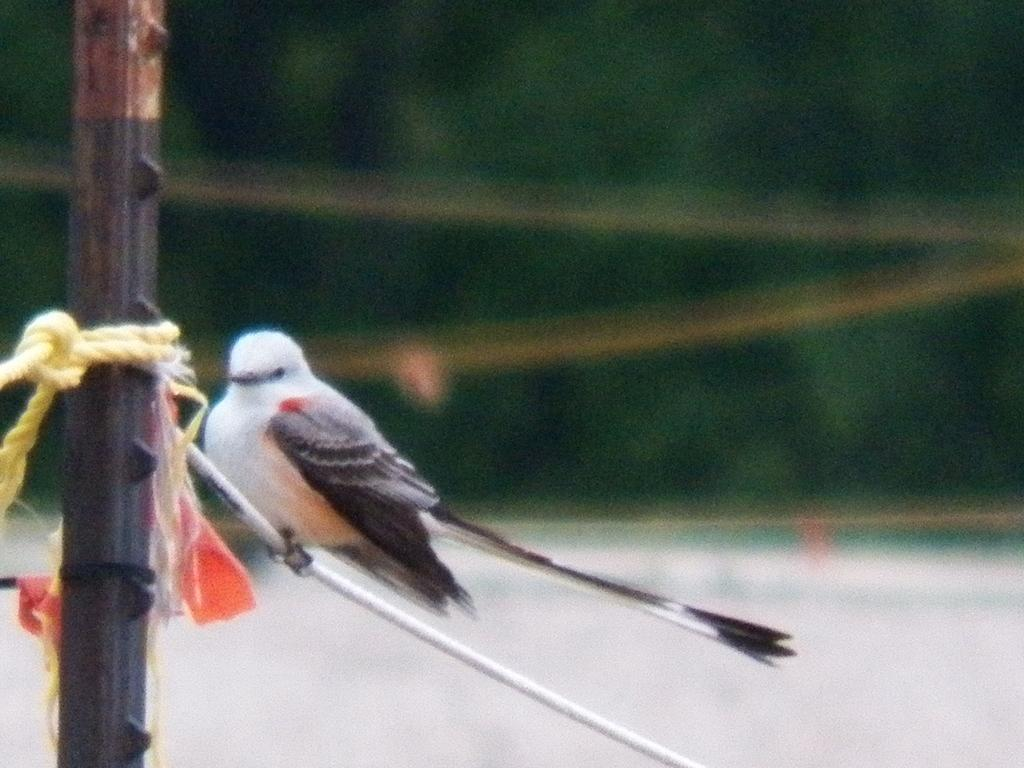What type of animal is present in the image? There is a bird in the image. Where is the bird located? The bird is on a white colored object. What other objects can be seen in the image? There is a pole, a rope, and some cloth in the image. How would you describe the background of the image? The background of the image is blurred. What type of battle is taking place in the image? There is no battle present in the image; it features a bird on a white object with other objects nearby. What color is the dad's shirt in the image? There is no dad present in the image, so we cannot determine the color of his shirt. 